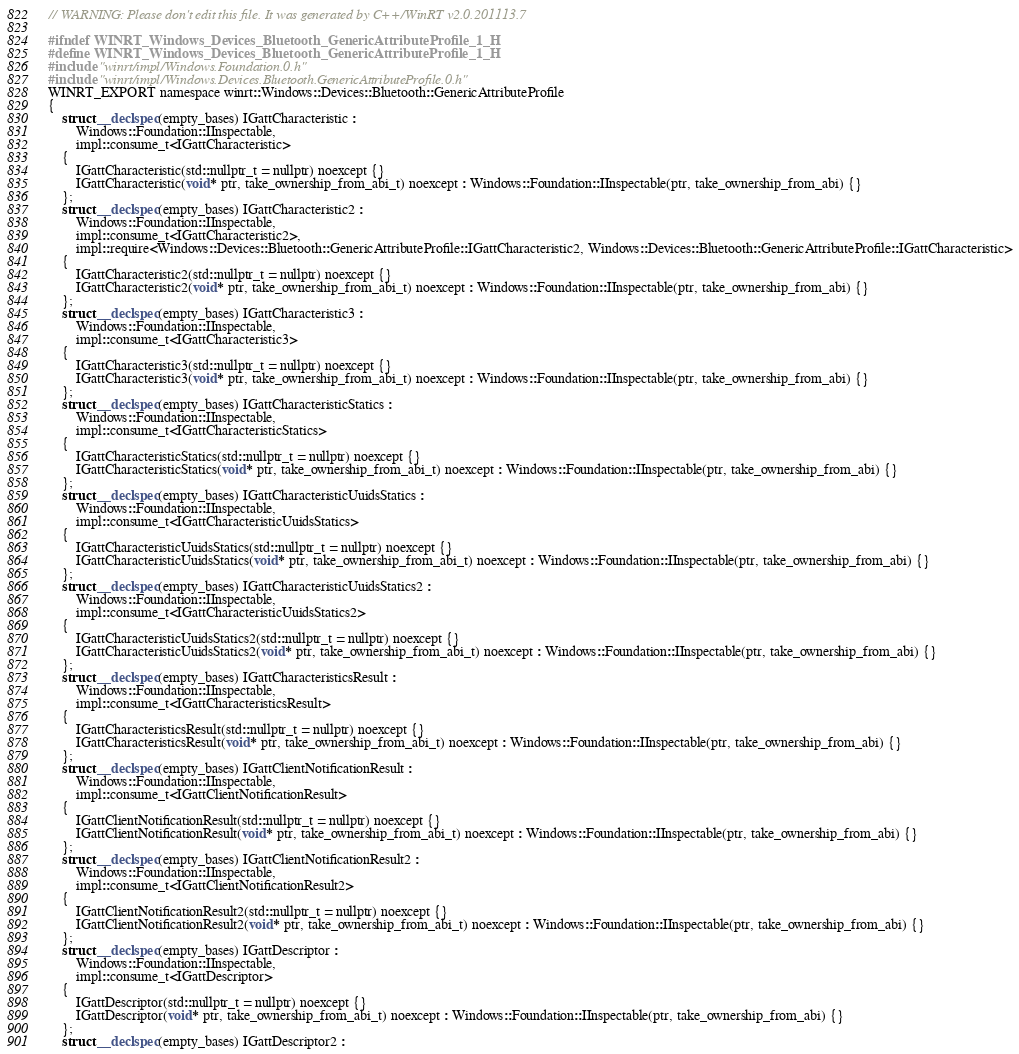<code> <loc_0><loc_0><loc_500><loc_500><_C_>// WARNING: Please don't edit this file. It was generated by C++/WinRT v2.0.201113.7

#ifndef WINRT_Windows_Devices_Bluetooth_GenericAttributeProfile_1_H
#define WINRT_Windows_Devices_Bluetooth_GenericAttributeProfile_1_H
#include "winrt/impl/Windows.Foundation.0.h"
#include "winrt/impl/Windows.Devices.Bluetooth.GenericAttributeProfile.0.h"
WINRT_EXPORT namespace winrt::Windows::Devices::Bluetooth::GenericAttributeProfile
{
    struct __declspec(empty_bases) IGattCharacteristic :
        Windows::Foundation::IInspectable,
        impl::consume_t<IGattCharacteristic>
    {
        IGattCharacteristic(std::nullptr_t = nullptr) noexcept {}
        IGattCharacteristic(void* ptr, take_ownership_from_abi_t) noexcept : Windows::Foundation::IInspectable(ptr, take_ownership_from_abi) {}
    };
    struct __declspec(empty_bases) IGattCharacteristic2 :
        Windows::Foundation::IInspectable,
        impl::consume_t<IGattCharacteristic2>,
        impl::require<Windows::Devices::Bluetooth::GenericAttributeProfile::IGattCharacteristic2, Windows::Devices::Bluetooth::GenericAttributeProfile::IGattCharacteristic>
    {
        IGattCharacteristic2(std::nullptr_t = nullptr) noexcept {}
        IGattCharacteristic2(void* ptr, take_ownership_from_abi_t) noexcept : Windows::Foundation::IInspectable(ptr, take_ownership_from_abi) {}
    };
    struct __declspec(empty_bases) IGattCharacteristic3 :
        Windows::Foundation::IInspectable,
        impl::consume_t<IGattCharacteristic3>
    {
        IGattCharacteristic3(std::nullptr_t = nullptr) noexcept {}
        IGattCharacteristic3(void* ptr, take_ownership_from_abi_t) noexcept : Windows::Foundation::IInspectable(ptr, take_ownership_from_abi) {}
    };
    struct __declspec(empty_bases) IGattCharacteristicStatics :
        Windows::Foundation::IInspectable,
        impl::consume_t<IGattCharacteristicStatics>
    {
        IGattCharacteristicStatics(std::nullptr_t = nullptr) noexcept {}
        IGattCharacteristicStatics(void* ptr, take_ownership_from_abi_t) noexcept : Windows::Foundation::IInspectable(ptr, take_ownership_from_abi) {}
    };
    struct __declspec(empty_bases) IGattCharacteristicUuidsStatics :
        Windows::Foundation::IInspectable,
        impl::consume_t<IGattCharacteristicUuidsStatics>
    {
        IGattCharacteristicUuidsStatics(std::nullptr_t = nullptr) noexcept {}
        IGattCharacteristicUuidsStatics(void* ptr, take_ownership_from_abi_t) noexcept : Windows::Foundation::IInspectable(ptr, take_ownership_from_abi) {}
    };
    struct __declspec(empty_bases) IGattCharacteristicUuidsStatics2 :
        Windows::Foundation::IInspectable,
        impl::consume_t<IGattCharacteristicUuidsStatics2>
    {
        IGattCharacteristicUuidsStatics2(std::nullptr_t = nullptr) noexcept {}
        IGattCharacteristicUuidsStatics2(void* ptr, take_ownership_from_abi_t) noexcept : Windows::Foundation::IInspectable(ptr, take_ownership_from_abi) {}
    };
    struct __declspec(empty_bases) IGattCharacteristicsResult :
        Windows::Foundation::IInspectable,
        impl::consume_t<IGattCharacteristicsResult>
    {
        IGattCharacteristicsResult(std::nullptr_t = nullptr) noexcept {}
        IGattCharacteristicsResult(void* ptr, take_ownership_from_abi_t) noexcept : Windows::Foundation::IInspectable(ptr, take_ownership_from_abi) {}
    };
    struct __declspec(empty_bases) IGattClientNotificationResult :
        Windows::Foundation::IInspectable,
        impl::consume_t<IGattClientNotificationResult>
    {
        IGattClientNotificationResult(std::nullptr_t = nullptr) noexcept {}
        IGattClientNotificationResult(void* ptr, take_ownership_from_abi_t) noexcept : Windows::Foundation::IInspectable(ptr, take_ownership_from_abi) {}
    };
    struct __declspec(empty_bases) IGattClientNotificationResult2 :
        Windows::Foundation::IInspectable,
        impl::consume_t<IGattClientNotificationResult2>
    {
        IGattClientNotificationResult2(std::nullptr_t = nullptr) noexcept {}
        IGattClientNotificationResult2(void* ptr, take_ownership_from_abi_t) noexcept : Windows::Foundation::IInspectable(ptr, take_ownership_from_abi) {}
    };
    struct __declspec(empty_bases) IGattDescriptor :
        Windows::Foundation::IInspectable,
        impl::consume_t<IGattDescriptor>
    {
        IGattDescriptor(std::nullptr_t = nullptr) noexcept {}
        IGattDescriptor(void* ptr, take_ownership_from_abi_t) noexcept : Windows::Foundation::IInspectable(ptr, take_ownership_from_abi) {}
    };
    struct __declspec(empty_bases) IGattDescriptor2 :</code> 